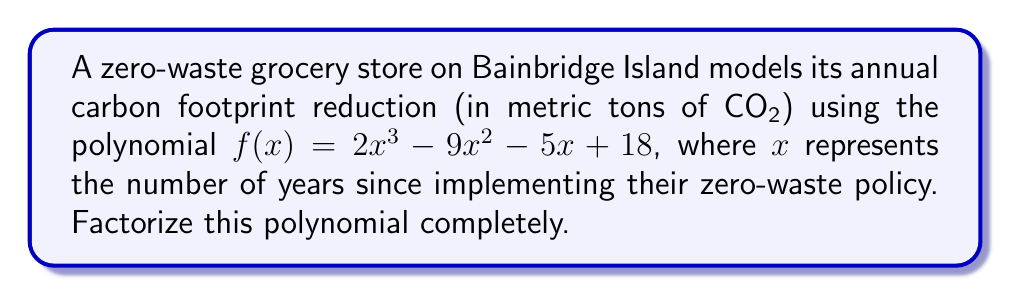Can you answer this question? To factorize this polynomial, we'll follow these steps:

1) First, let's check if there are any common factors. In this case, there are none.

2) Next, we'll use the rational root theorem to find potential roots. The possible rational roots are the factors of the constant term (18): ±1, ±2, ±3, ±6, ±9, ±18

3) Let's test these values:
   $f(1) = 2 - 9 - 5 + 18 = 6$
   $f(-1) = -2 - 9 + 5 + 18 = 12$
   $f(2) = 16 - 36 - 10 + 18 = -12$
   $f(3) = 54 - 81 - 15 + 18 = -24$
   $f(-2) = -16 - 36 + 10 + 18 = -24$
   $f(-3) = -54 - 81 + 15 + 18 = -102$

4) We find that $f(2) = -12$ and $f(-3) = -102$. Since $f(2)$ is closer to zero, let's use synthetic division with 2:

   $$
   \begin{array}{r}
   2 \enclose{longdiv}{2x^3 - 9x^2 - 5x + 18} \\
   \underline{2x^3 + 4x^2} \\
   -13x^2 - 5x \\
   \underline{-13x^2 - 26x} \\
   21x + 18 \\
   \underline{21x + 42} \\
   -24
   \end{array}
   $$

5) This gives us: $f(x) = (x - 2)(2x^2 + 4x - 9)$

6) Now we need to factor the quadratic $2x^2 + 4x - 9$. Its discriminant is:
   $b^2 - 4ac = 4^2 - 4(2)(-9) = 16 + 72 = 88 = 4 \cdot 22$

7) The roots of this quadratic are:
   $$x = \frac{-4 \pm \sqrt{88}}{2(2)} = \frac{-4 \pm 2\sqrt{22}}{4} = -1 \pm \frac{\sqrt{22}}{2}$$

8) Therefore, the quadratic factors as:
   $2x^2 + 4x - 9 = 2(x + 1 + \frac{\sqrt{22}}{2})(x + 1 - \frac{\sqrt{22}}{2})$

9) Putting it all together:
   $f(x) = (x - 2)(2)(x + 1 + \frac{\sqrt{22}}{2})(x + 1 - \frac{\sqrt{22}}{2})$
Answer: $f(x) = 2(x - 2)(x + 1 + \frac{\sqrt{22}}{2})(x + 1 - \frac{\sqrt{22}}{2})$ 